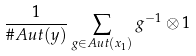Convert formula to latex. <formula><loc_0><loc_0><loc_500><loc_500>\frac { 1 } { \# A u t ( y ) } \sum _ { g \in A u t ( x _ { 1 } ) } g ^ { - 1 } \otimes 1</formula> 